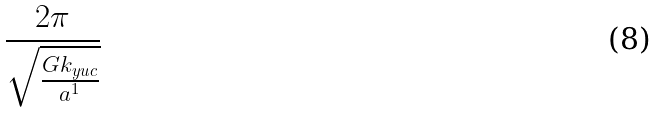<formula> <loc_0><loc_0><loc_500><loc_500>\frac { 2 \pi } { \sqrt { \frac { G k _ { y u c } } { a ^ { 1 } } } }</formula> 